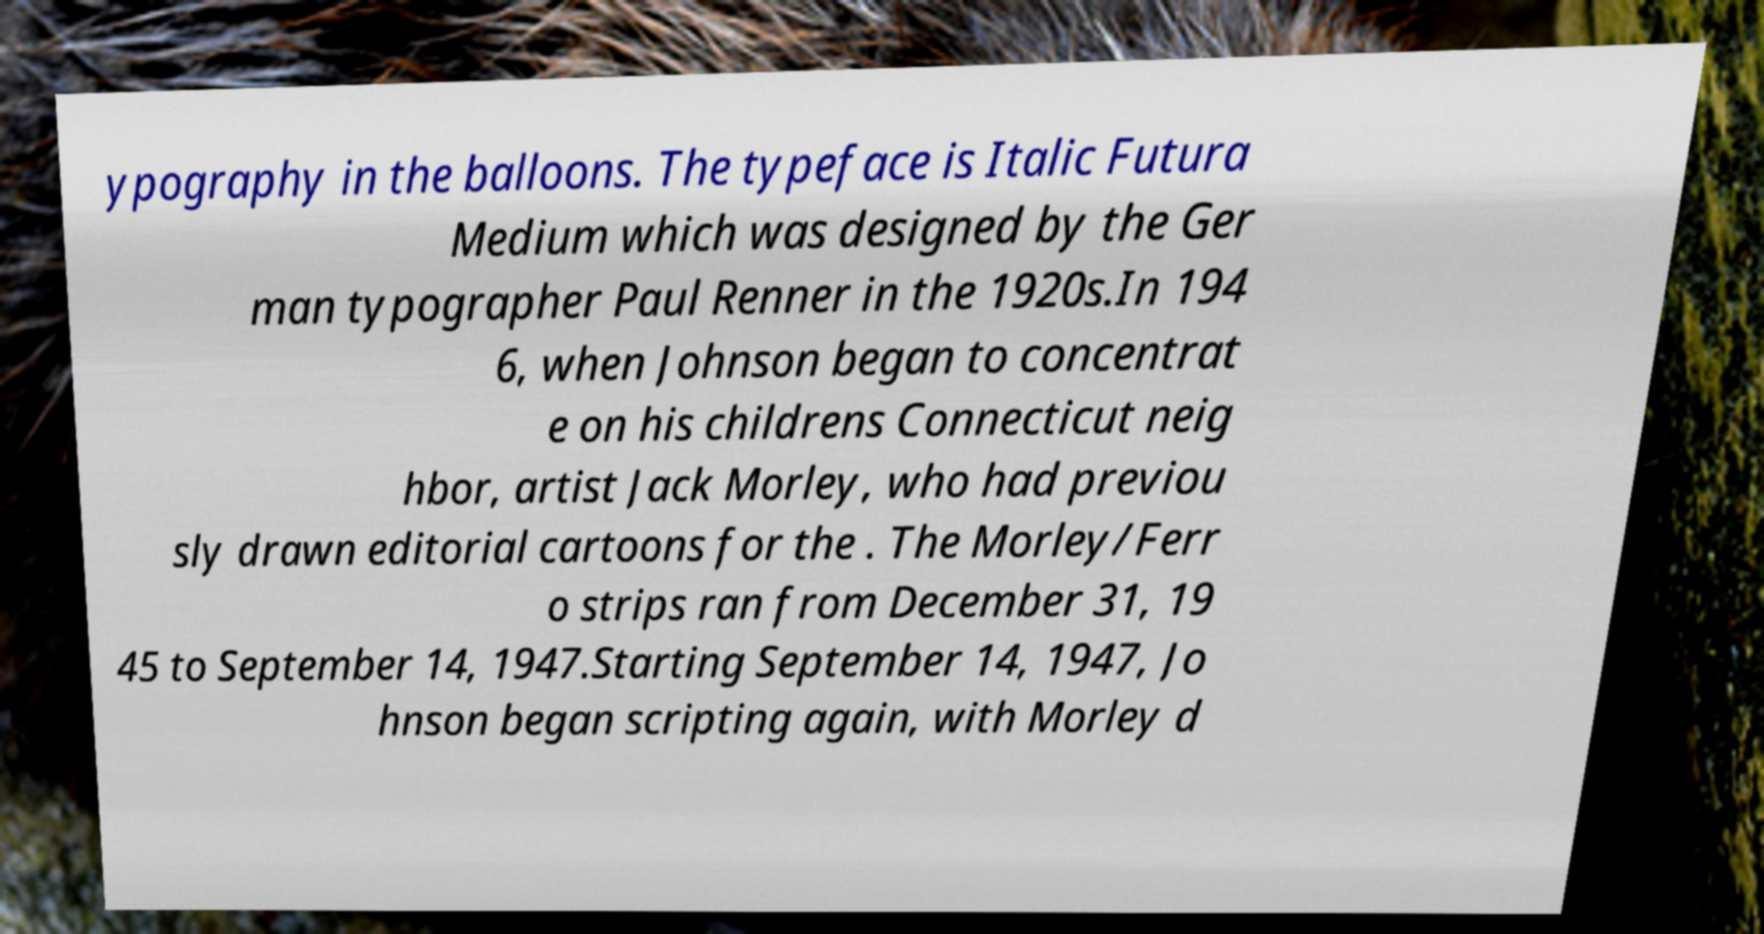Could you extract and type out the text from this image? ypography in the balloons. The typeface is Italic Futura Medium which was designed by the Ger man typographer Paul Renner in the 1920s.In 194 6, when Johnson began to concentrat e on his childrens Connecticut neig hbor, artist Jack Morley, who had previou sly drawn editorial cartoons for the . The Morley/Ferr o strips ran from December 31, 19 45 to September 14, 1947.Starting September 14, 1947, Jo hnson began scripting again, with Morley d 